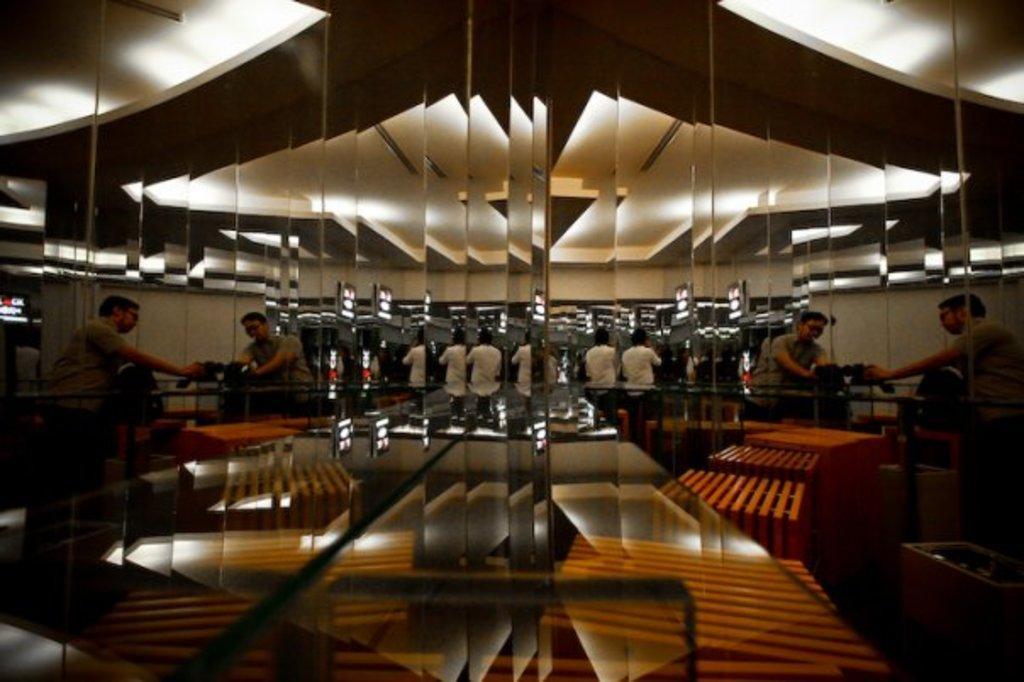Can you describe this image briefly? In this image I can see people are standing in-front of the machines. These people with white and grey color dresses and I can see many lights in the back. To the left I can see the screen. And there is a table in the front. 